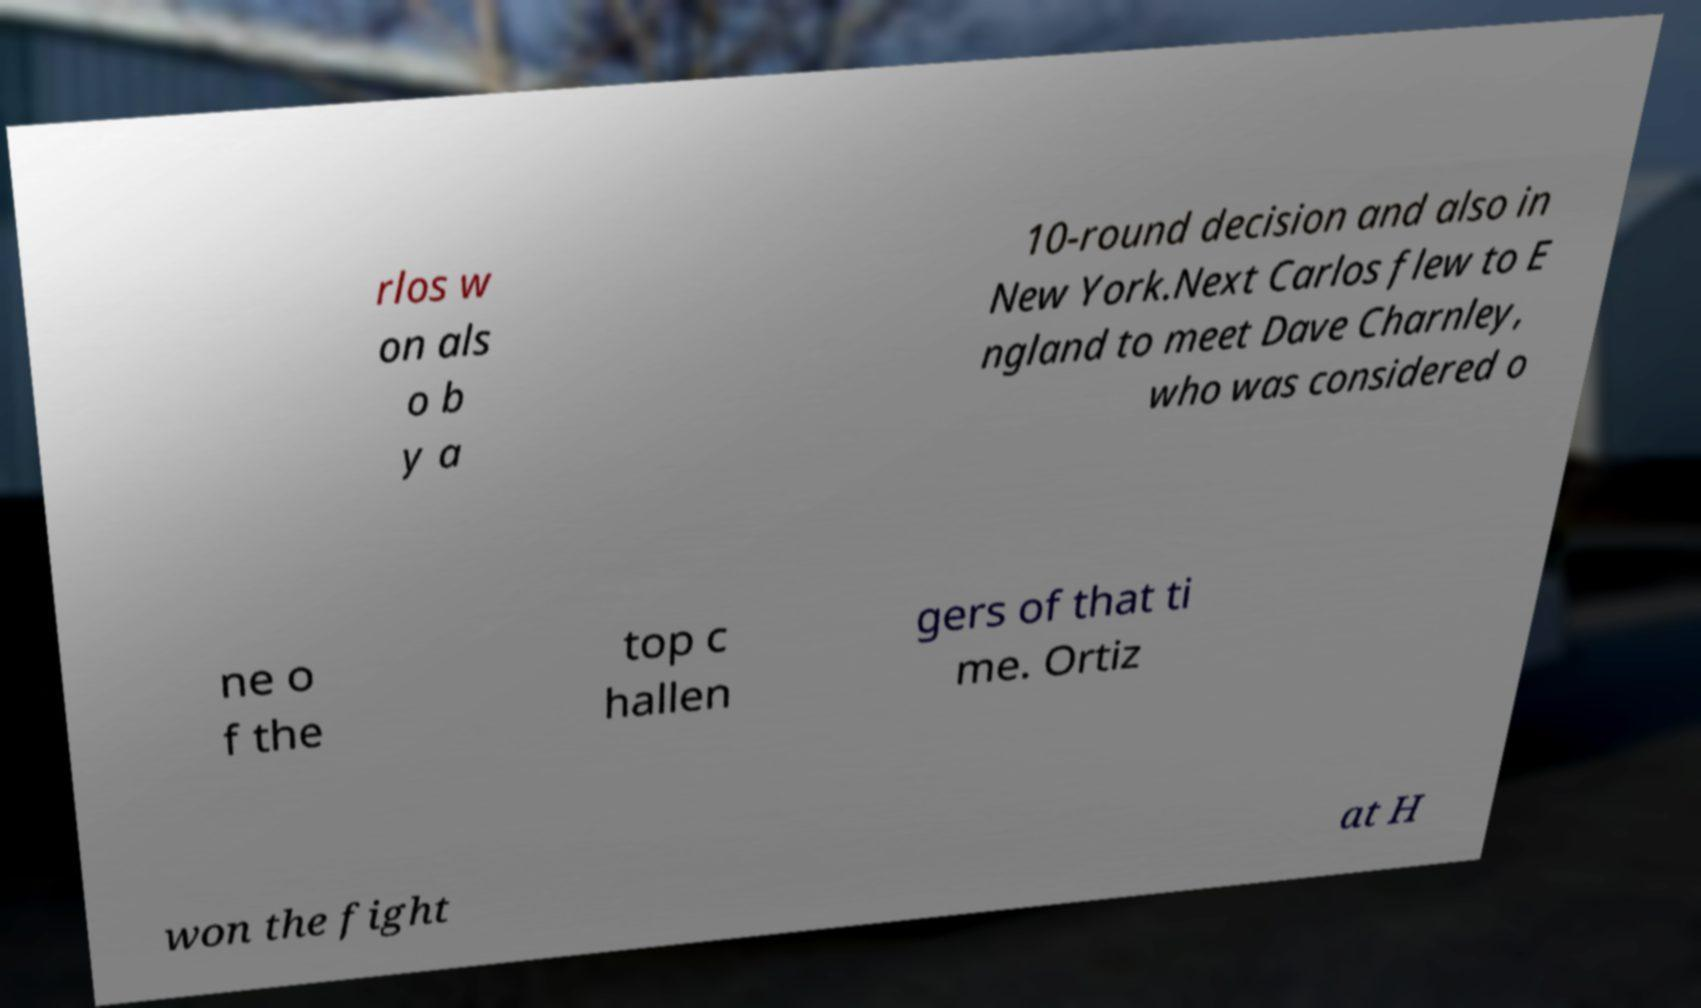Please identify and transcribe the text found in this image. rlos w on als o b y a 10-round decision and also in New York.Next Carlos flew to E ngland to meet Dave Charnley, who was considered o ne o f the top c hallen gers of that ti me. Ortiz won the fight at H 